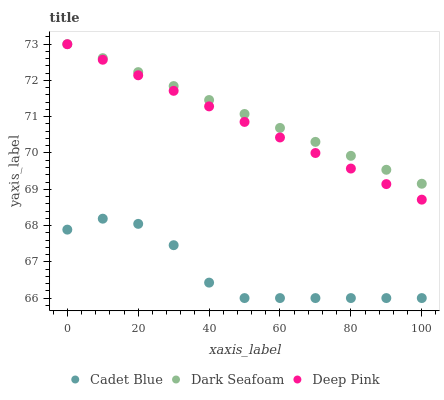Does Cadet Blue have the minimum area under the curve?
Answer yes or no. Yes. Does Dark Seafoam have the maximum area under the curve?
Answer yes or no. Yes. Does Deep Pink have the minimum area under the curve?
Answer yes or no. No. Does Deep Pink have the maximum area under the curve?
Answer yes or no. No. Is Dark Seafoam the smoothest?
Answer yes or no. Yes. Is Cadet Blue the roughest?
Answer yes or no. Yes. Is Deep Pink the smoothest?
Answer yes or no. No. Is Deep Pink the roughest?
Answer yes or no. No. Does Cadet Blue have the lowest value?
Answer yes or no. Yes. Does Deep Pink have the lowest value?
Answer yes or no. No. Does Deep Pink have the highest value?
Answer yes or no. Yes. Does Cadet Blue have the highest value?
Answer yes or no. No. Is Cadet Blue less than Deep Pink?
Answer yes or no. Yes. Is Dark Seafoam greater than Cadet Blue?
Answer yes or no. Yes. Does Dark Seafoam intersect Deep Pink?
Answer yes or no. Yes. Is Dark Seafoam less than Deep Pink?
Answer yes or no. No. Is Dark Seafoam greater than Deep Pink?
Answer yes or no. No. Does Cadet Blue intersect Deep Pink?
Answer yes or no. No. 